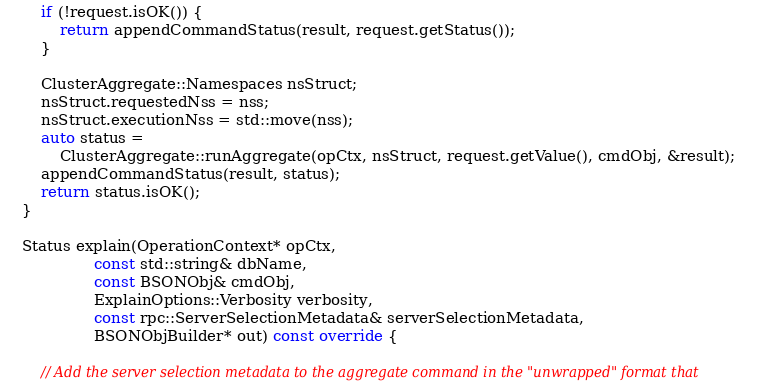<code> <loc_0><loc_0><loc_500><loc_500><_C++_>        if (!request.isOK()) {
            return appendCommandStatus(result, request.getStatus());
        }

        ClusterAggregate::Namespaces nsStruct;
        nsStruct.requestedNss = nss;
        nsStruct.executionNss = std::move(nss);
        auto status =
            ClusterAggregate::runAggregate(opCtx, nsStruct, request.getValue(), cmdObj, &result);
        appendCommandStatus(result, status);
        return status.isOK();
    }

    Status explain(OperationContext* opCtx,
                   const std::string& dbName,
                   const BSONObj& cmdObj,
                   ExplainOptions::Verbosity verbosity,
                   const rpc::ServerSelectionMetadata& serverSelectionMetadata,
                   BSONObjBuilder* out) const override {

        // Add the server selection metadata to the aggregate command in the "unwrapped" format that</code> 